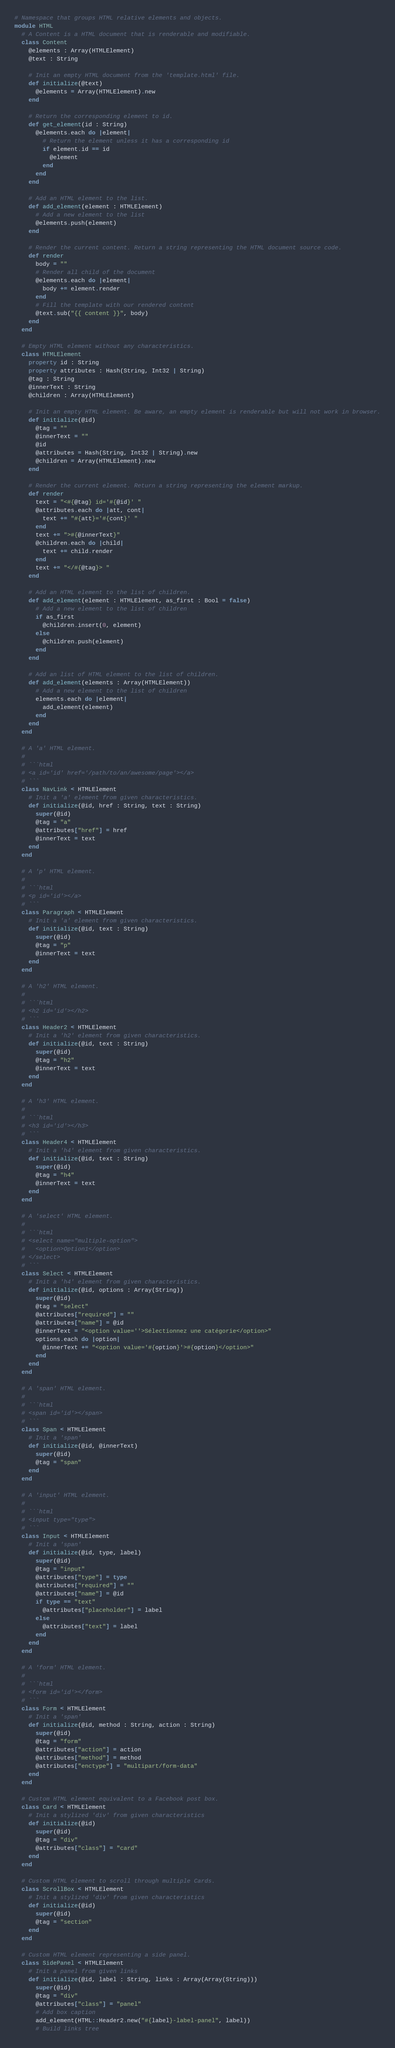<code> <loc_0><loc_0><loc_500><loc_500><_Crystal_># Namespace that groups HTML relative elements and objects.
module HTML
  # A Content is a HTML document that is renderable and modifiable.
  class Content
    @elements : Array(HTMLElement)
    @text : String

    # Init an empty HTML document from the 'template.html' file.
    def initialize(@text)
      @elements = Array(HTMLElement).new
    end

    # Return the corresponding element to id.
    def get_element(id : String)
      @elements.each do |element|
        # Return the element unless it has a corresponding id
        if element.id == id
          @element
        end
      end
    end

    # Add an HTML element to the list.
    def add_element(element : HTMLElement)
      # Add a new element to the list
      @elements.push(element)
    end

    # Render the current content. Return a string representing the HTML document source code.
    def render
      body = ""
      # Render all child of the document
      @elements.each do |element|
        body += element.render
      end
      # Fill the template with our rendered content
      @text.sub("{{ content }}", body)
    end
  end

  # Empty HTML element without any characteristics.
  class HTMLElement
    property id : String
    property attributes : Hash(String, Int32 | String)
    @tag : String
    @innerText : String
    @children : Array(HTMLElement)

    # Init an empty HTML element. Be aware, an empty element is renderable but will not work in browser.
    def initialize(@id)
      @tag = ""
      @innerText = ""
      @id
      @attributes = Hash(String, Int32 | String).new
      @children = Array(HTMLElement).new
    end

    # Render the current element. Return a string representing the element markup.
    def render
      text = "<#{@tag} id='#{@id}' "
      @attributes.each do |att, cont|
        text += "#{att}='#{cont}' "
      end
      text += ">#{@innerText}"
      @children.each do |child|
        text += child.render
      end
      text += "</#{@tag}> "
    end

    # Add an HTML element to the list of children.
    def add_element(element : HTMLElement, as_first : Bool = false)
      # Add a new element to the list of children
      if as_first
        @children.insert(0, element)
      else
        @children.push(element)
      end
    end

    # Add an list of HTML element to the list of children.
    def add_element(elements : Array(HTMLElement))
      # Add a new element to the list of children
      elements.each do |element|
        add_element(element)
      end
    end
  end

  # A 'a' HTML element.
  #
  # ```html
  # <a id='id' href='/path/to/an/awesome/page'></a>
  # ```
  class NavLink < HTMLElement
    # Init a 'a' element from given characteristics.
    def initialize(@id, href : String, text : String)
      super(@id)
      @tag = "a"
      @attributes["href"] = href
      @innerText = text
    end
  end

  # A 'p' HTML element.
  #
  # ```html
  # <p id='id'></a>
  # ```
  class Paragraph < HTMLElement
    # Init a 'a' element from given characteristics.
    def initialize(@id, text : String)
      super(@id)
      @tag = "p"
      @innerText = text
    end
  end

  # A 'h2' HTML element.
  #
  # ```html
  # <h2 id='id'></h2>
  # ```
  class Header2 < HTMLElement
    # Init a 'h2' element from given characteristics.
    def initialize(@id, text : String)
      super(@id)
      @tag = "h2"
      @innerText = text
    end
  end

  # A 'h3' HTML element.
  #
  # ```html
  # <h3 id='id'></h3>
  # ```
  class Header4 < HTMLElement
    # Init a 'h4' element from given characteristics.
    def initialize(@id, text : String)
      super(@id)
      @tag = "h4"
      @innerText = text
    end
  end

  # A 'select' HTML element.
  #
  # ```html
  # <select name="multiple-option">
  #   <option>Option1</option>
  # </select>
  # ```
  class Select < HTMLElement
    # Init a 'h4' element from given characteristics.
    def initialize(@id, options : Array(String))
      super(@id)
      @tag = "select"
      @attributes["required"] = ""
      @attributes["name"] = @id
      @innerText = "<option value=''>Sélectionnez une catégorie</option>"
      options.each do |option|
        @innerText += "<option value='#{option}'>#{option}</option>"
      end
    end
  end

  # A 'span' HTML element.
  #
  # ```html
  # <span id='id'></span>
  # ```
  class Span < HTMLElement
    # Init a 'span'
    def initialize(@id, @innerText)
      super(@id)
      @tag = "span"
    end
  end

  # A 'input' HTML element.
  #
  # ```html
  # <input type="type">
  # ```
  class Input < HTMLElement
    # Init a 'span'
    def initialize(@id, type, label)
      super(@id)
      @tag = "input"
      @attributes["type"] = type
      @attributes["required"] = ""
      @attributes["name"] = @id
      if type == "text"
        @attributes["placeholder"] = label
      else
        @attributes["text"] = label
      end
    end
  end

  # A 'form' HTML element.
  #
  # ```html
  # <form id='id'></form>
  # ```
  class Form < HTMLElement
    # Init a 'span'
    def initialize(@id, method : String, action : String)
      super(@id)
      @tag = "form"
      @attributes["action"] = action
      @attributes["method"] = method
      @attributes["enctype"] = "multipart/form-data"
    end
  end

  # Custom HTML element equivalent to a Facebook post box.
  class Card < HTMLElement
    # Init a stylized 'div' from given characteristics
    def initialize(@id)
      super(@id)
      @tag = "div"
      @attributes["class"] = "card"
    end
  end

  # Custom HTML element to scroll through multiple Cards.
  class ScrollBox < HTMLElement
    # Init a stylized 'div' from given characteristics
    def initialize(@id)
      super(@id)
      @tag = "section"
    end
  end

  # Custom HTML element representing a side panel.
  class SidePanel < HTMLElement
    # Init a panel from given links
    def initialize(@id, label : String, links : Array(Array(String)))
      super(@id)
      @tag = "div"
      @attributes["class"] = "panel"
      # Add box caption
      add_element(HTML::Header2.new("#{label}-label-panel", label))
      # Build links tree</code> 